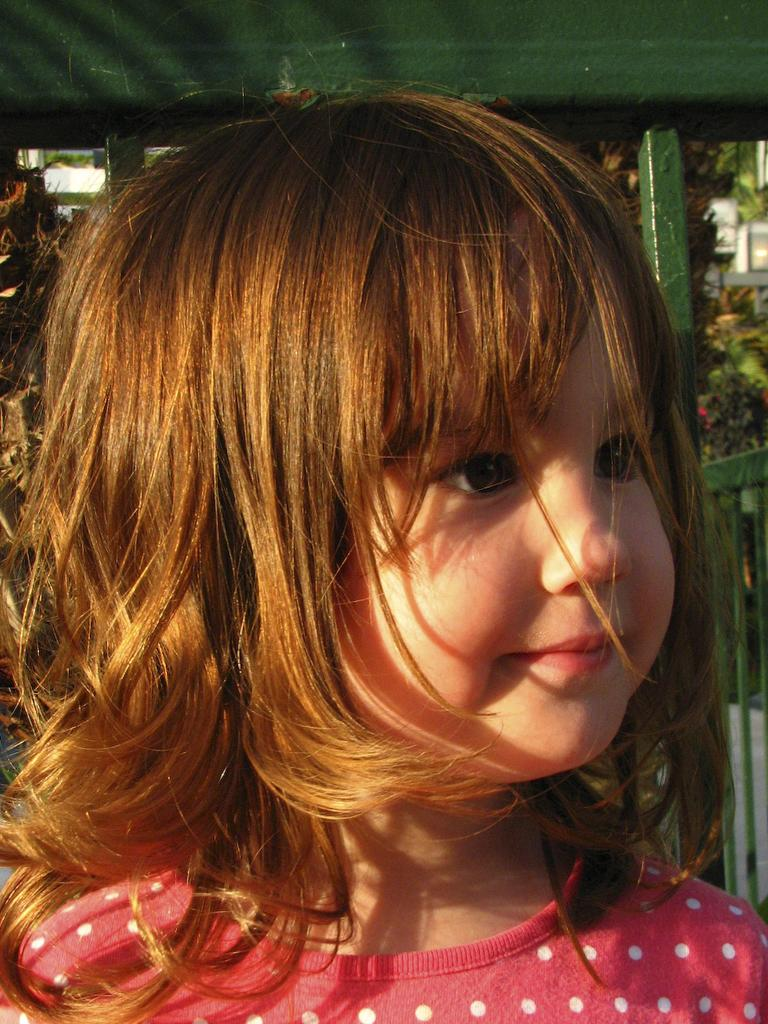Who is the main subject in the image? There is a girl in the image. What is the girl doing in the image? The girl is looking at someone. What type of hall can be seen in the image? There is no hall present in the image; it only features a girl looking at someone. What is the source of light in the image? The provided facts do not mention any light source in the image. 